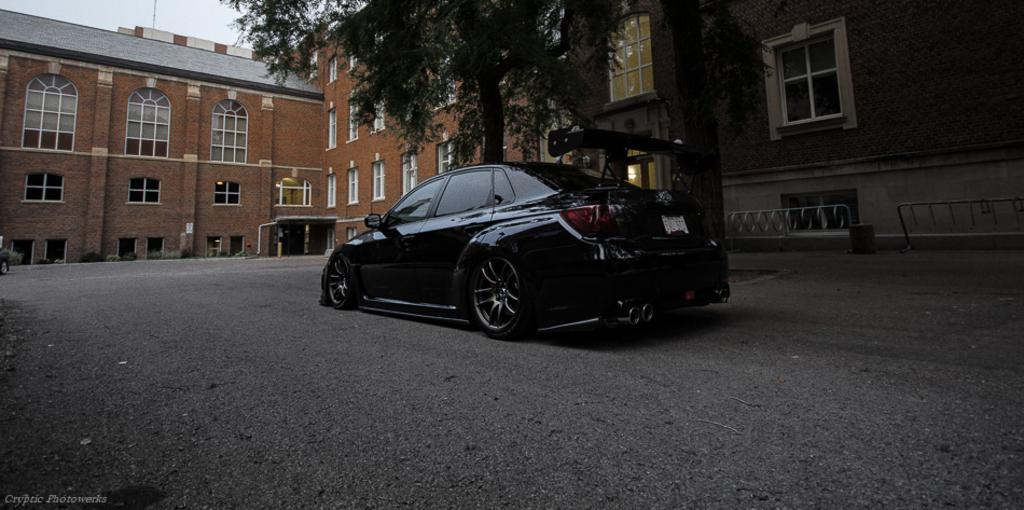What type of motor vehicle is on the road in the image? The fact does not specify the type of motor vehicle, but there is a motor vehicle on the road. What structures can be seen in the image? There are buildings, iron grills, bins, and electric lights visible in the image. What architectural features are present in the image? Iron grills and windows are present in the image. What type of vegetation is visible in the image? Trees are visible in the image. What is visible in the sky in the image? The sky is visible in the image. How far away is the fire in the image? There is no fire present in the image. What type of journey is depicted in the image? The image does not depict a journey; it shows a motor vehicle on the road, buildings, iron grills, bins, electric lights, windows, trees, and the sky. 